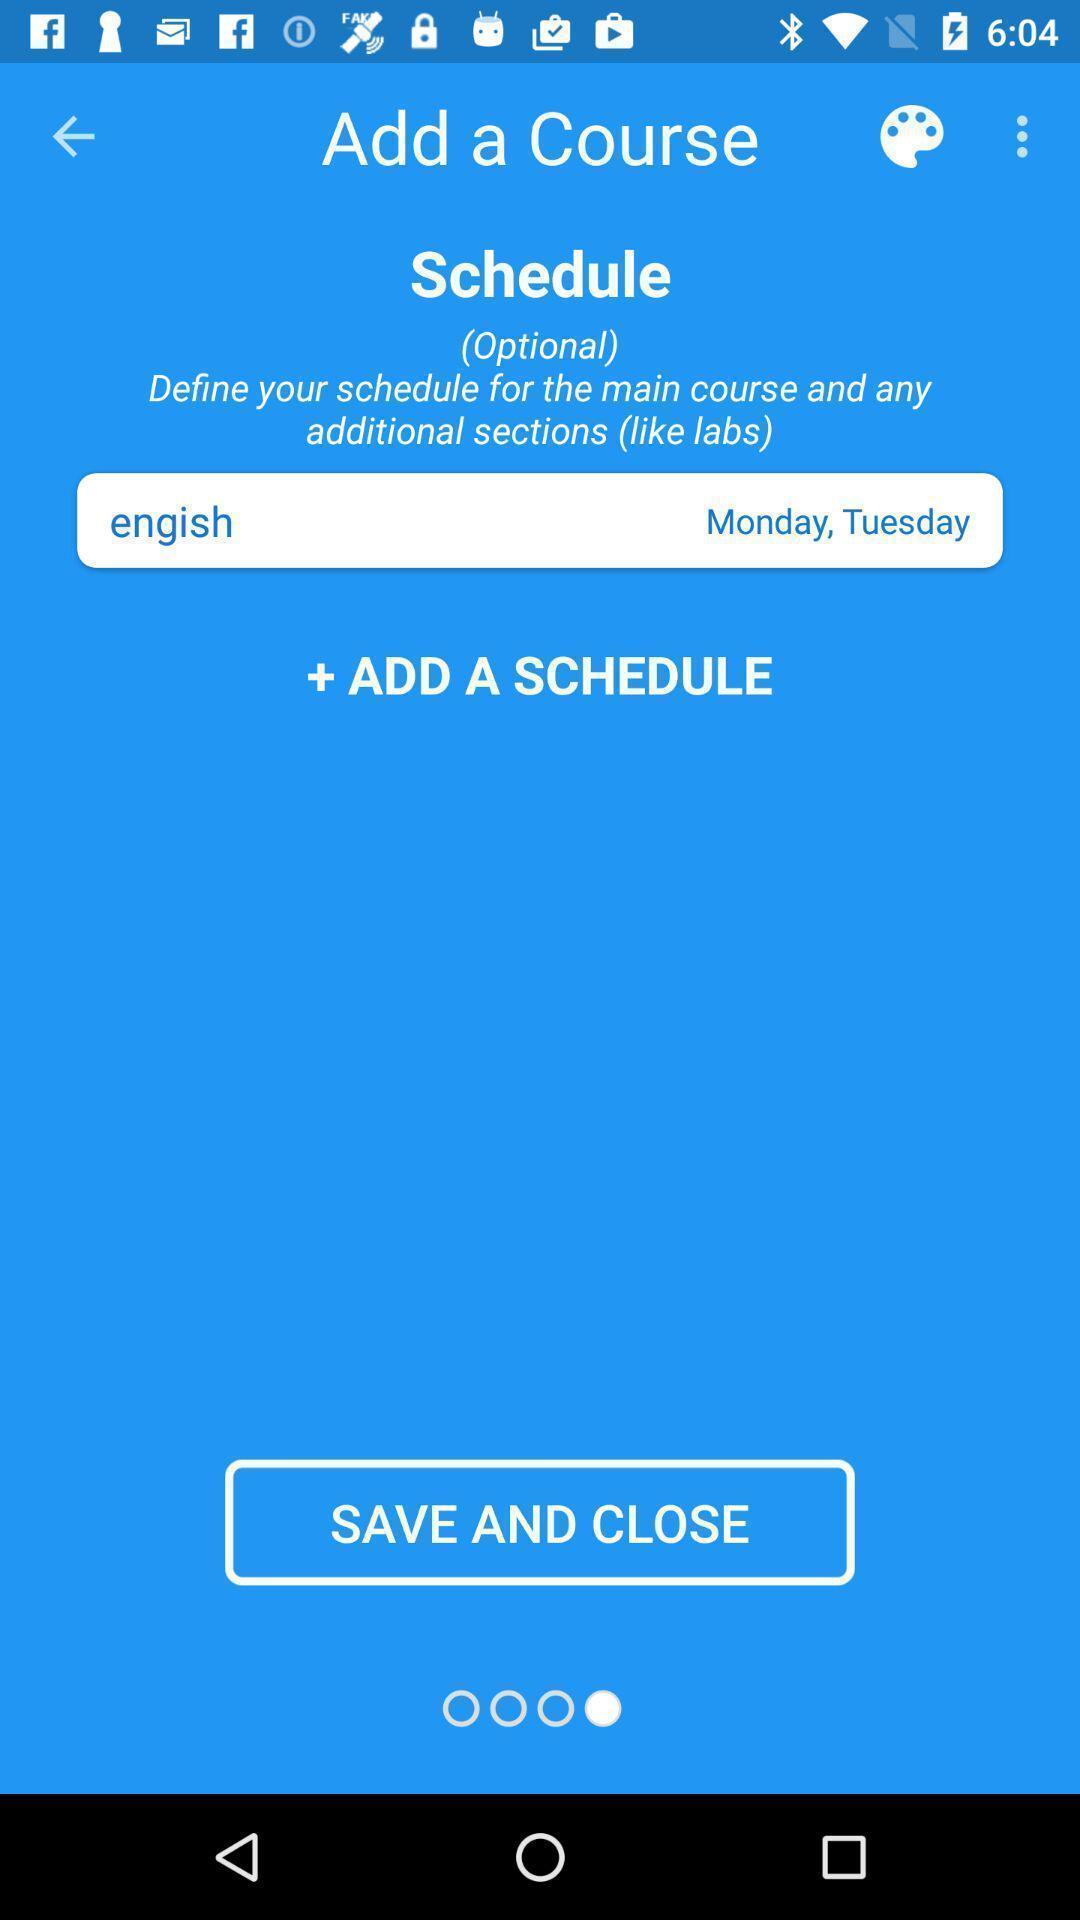What details can you identify in this image? Screen displaying the page asking to add a course. 